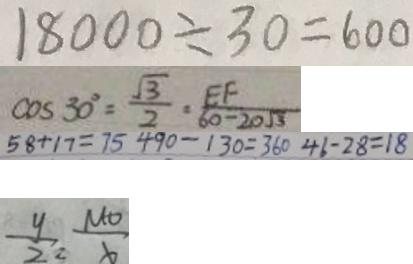<formula> <loc_0><loc_0><loc_500><loc_500>1 8 0 0 0 \div 3 0 = 6 0 0 
 \cos 3 0 ^ { \circ } = \frac { \sqrt { 3 } } { 2 } = \frac { E F } { 6 0 - 2 0 \sqrt { 3 } } 
 5 8 + 1 7 = 7 5 4 9 0 - 1 3 0 = 3 6 0 4 6 - 2 8 = 1 8 
 \frac { y } { 2 } , \frac { M O } { b }</formula> 